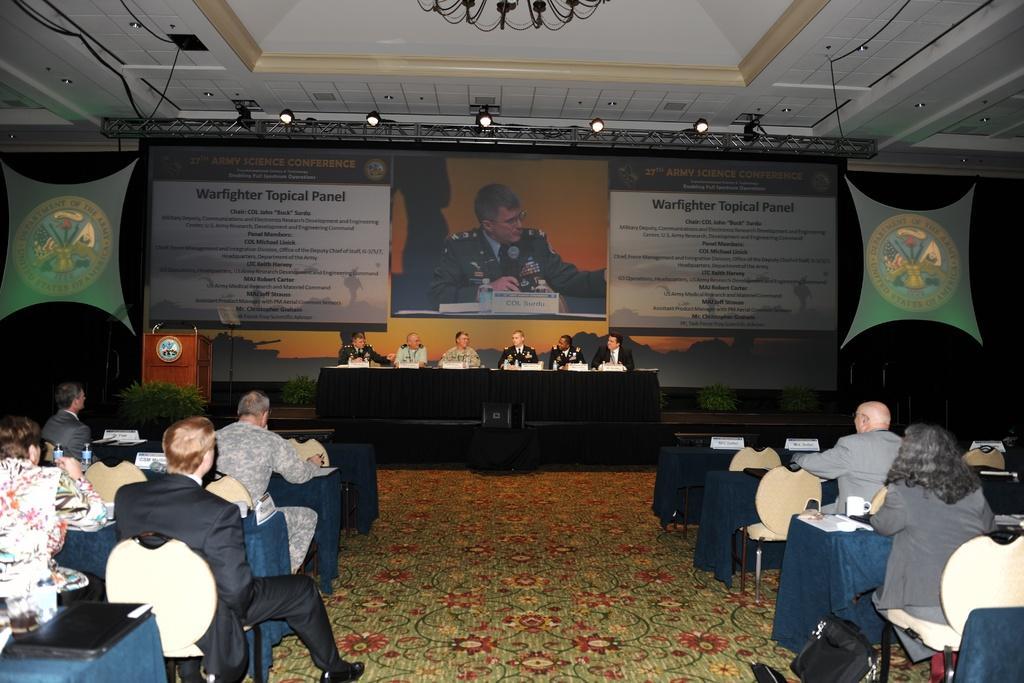How would you summarize this image in a sentence or two? There are group of people sitting in chairs in front of table there is a big screen projection. 